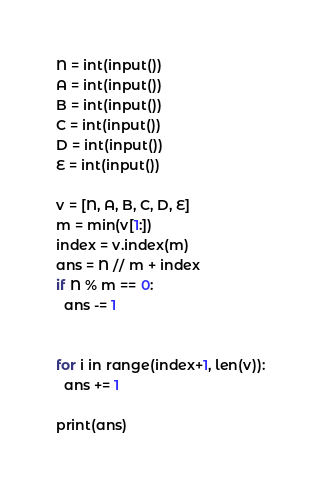<code> <loc_0><loc_0><loc_500><loc_500><_Python_>N = int(input())
A = int(input())
B = int(input())
C = int(input())
D = int(input())
E = int(input())

v = [N, A, B, C, D, E]
m = min(v[1:])
index = v.index(m)
ans = N // m + index
if N % m == 0:
  ans -= 1


for i in range(index+1, len(v)):
  ans += 1

print(ans)
</code> 